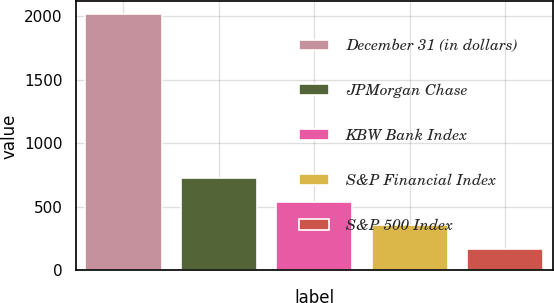Convert chart. <chart><loc_0><loc_0><loc_500><loc_500><bar_chart><fcel>December 31 (in dollars)<fcel>JPMorgan Chase<fcel>KBW Bank Index<fcel>S&P Financial Index<fcel>S&P 500 Index<nl><fcel>2016<fcel>724.34<fcel>539.82<fcel>355.3<fcel>170.78<nl></chart> 